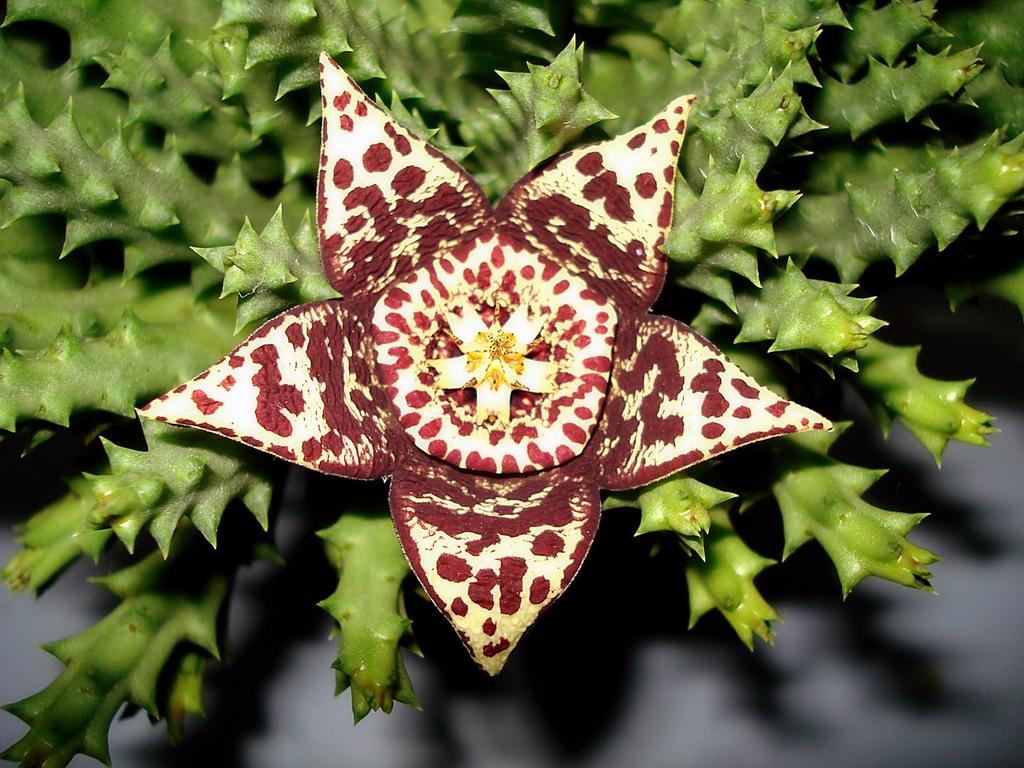What is the main subject of the image? There is a flower in the image. Can you describe the colors of the flower? The flower has white, brown, and yellow colors. What can be seen in the background of the image? There are plants in the background of the image. What color are the plants in the background? The plants are green in color. Is there a scarecrow in the image to guide the flower? No, there is no scarecrow present in the image. The flower is simply a subject in the image, and there is no indication of a scarecrow or any guiding element. 